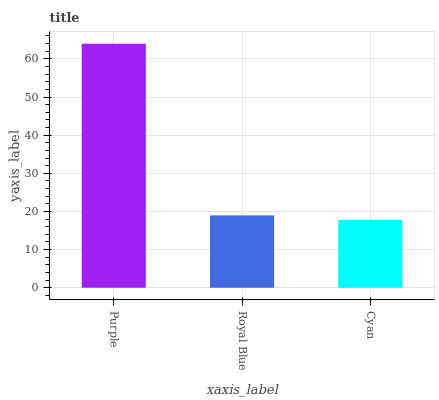Is Cyan the minimum?
Answer yes or no. Yes. Is Purple the maximum?
Answer yes or no. Yes. Is Royal Blue the minimum?
Answer yes or no. No. Is Royal Blue the maximum?
Answer yes or no. No. Is Purple greater than Royal Blue?
Answer yes or no. Yes. Is Royal Blue less than Purple?
Answer yes or no. Yes. Is Royal Blue greater than Purple?
Answer yes or no. No. Is Purple less than Royal Blue?
Answer yes or no. No. Is Royal Blue the high median?
Answer yes or no. Yes. Is Royal Blue the low median?
Answer yes or no. Yes. Is Purple the high median?
Answer yes or no. No. Is Purple the low median?
Answer yes or no. No. 